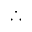Convert formula to latex. <formula><loc_0><loc_0><loc_500><loc_500>\therefore</formula> 